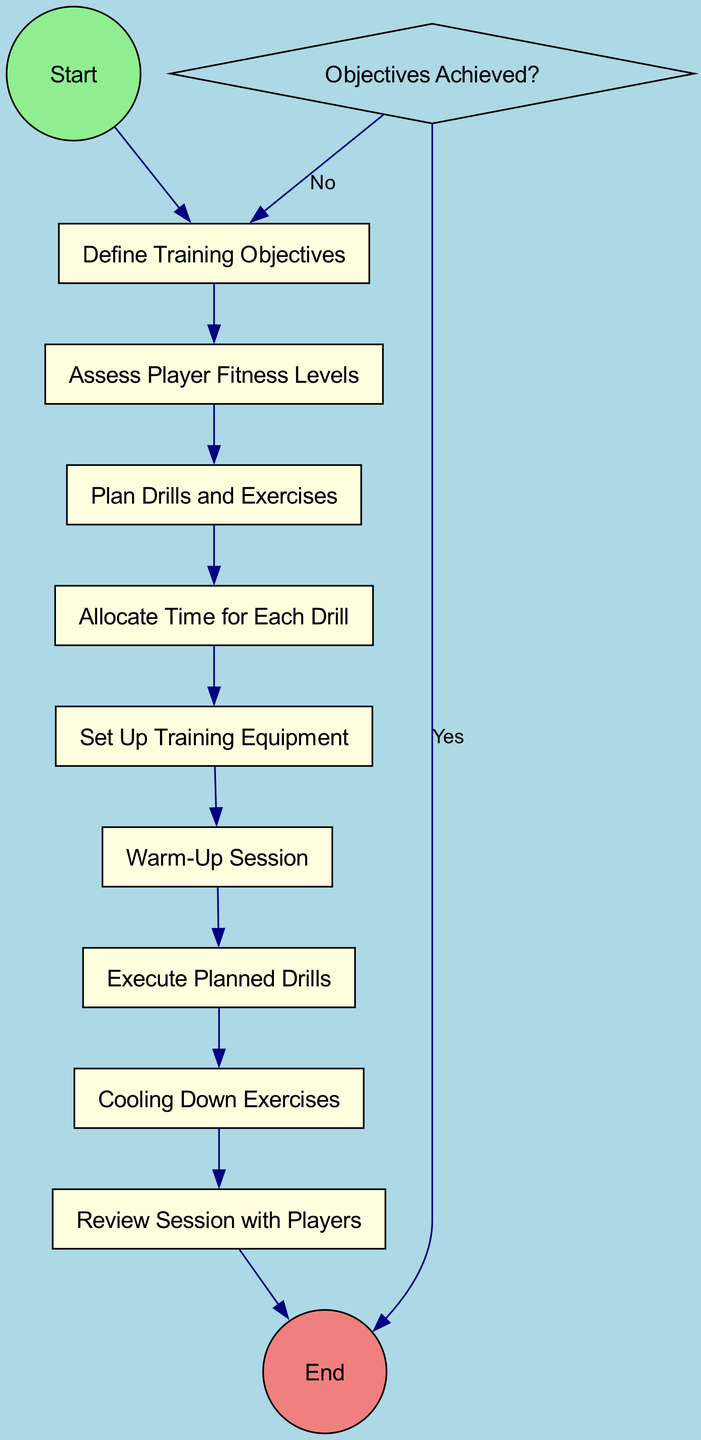What is the starting node called? The diagram begins with a node labeled "Start," which is designated as the starting point of the training session planning and execution process.
Answer: Start How many activities are there in total? By counting the nodes that are categorized as "Activity," I find there are six activities: Define Training Objectives, Assess Player Fitness Levels, Plan Drills and Exercises, Allocate Time for Each Drill, Set Up Training Equipment, and Warm-Up Session.
Answer: Six What is the first decision node in the diagram? The first decision node encountered when following the flow of the diagram is "Objectives Achieved?" which assesses whether the training objectives have been met.
Answer: Objectives Achieved? What are the last activities before the End node? The last activities prior to reaching the End node are "Cooling Down Exercises" and "Review Session with Players." These two activities occur right before the flow exits the diagram.
Answer: Cooling Down Exercises, Review Session with Players What happens if the answer to the decision node is 'No'? If the answer to the decision node "Objectives Achieved?" is 'No', the flow returns to the "Define Training Objectives" node to re-evaluate and establish the goals for the next session.
Answer: Return to Define Training Objectives How many drills and exercises are planned in the flow? The diagram specifies one main node labeled "Plan Drills and Exercises," indicating that these are integrated into the overall training session planning. Therefore, the answer is one planned node for drills and exercises.
Answer: One Which activity follows the "Set Up Training Equipment" activity? The activity that follows "Set Up Training Equipment" is "Warm-Up Session." This sequence is crucial as warming up typically occurs after the equipment is prepared.
Answer: Warm-Up Session Is there any node for evaluating player performance after drills? There is no specific node listed for evaluating player performance immediately after drills; instead, the evaluation process occurs during the "Review Session with Players" activity, indicating a later stage of performance assessment.
Answer: No 